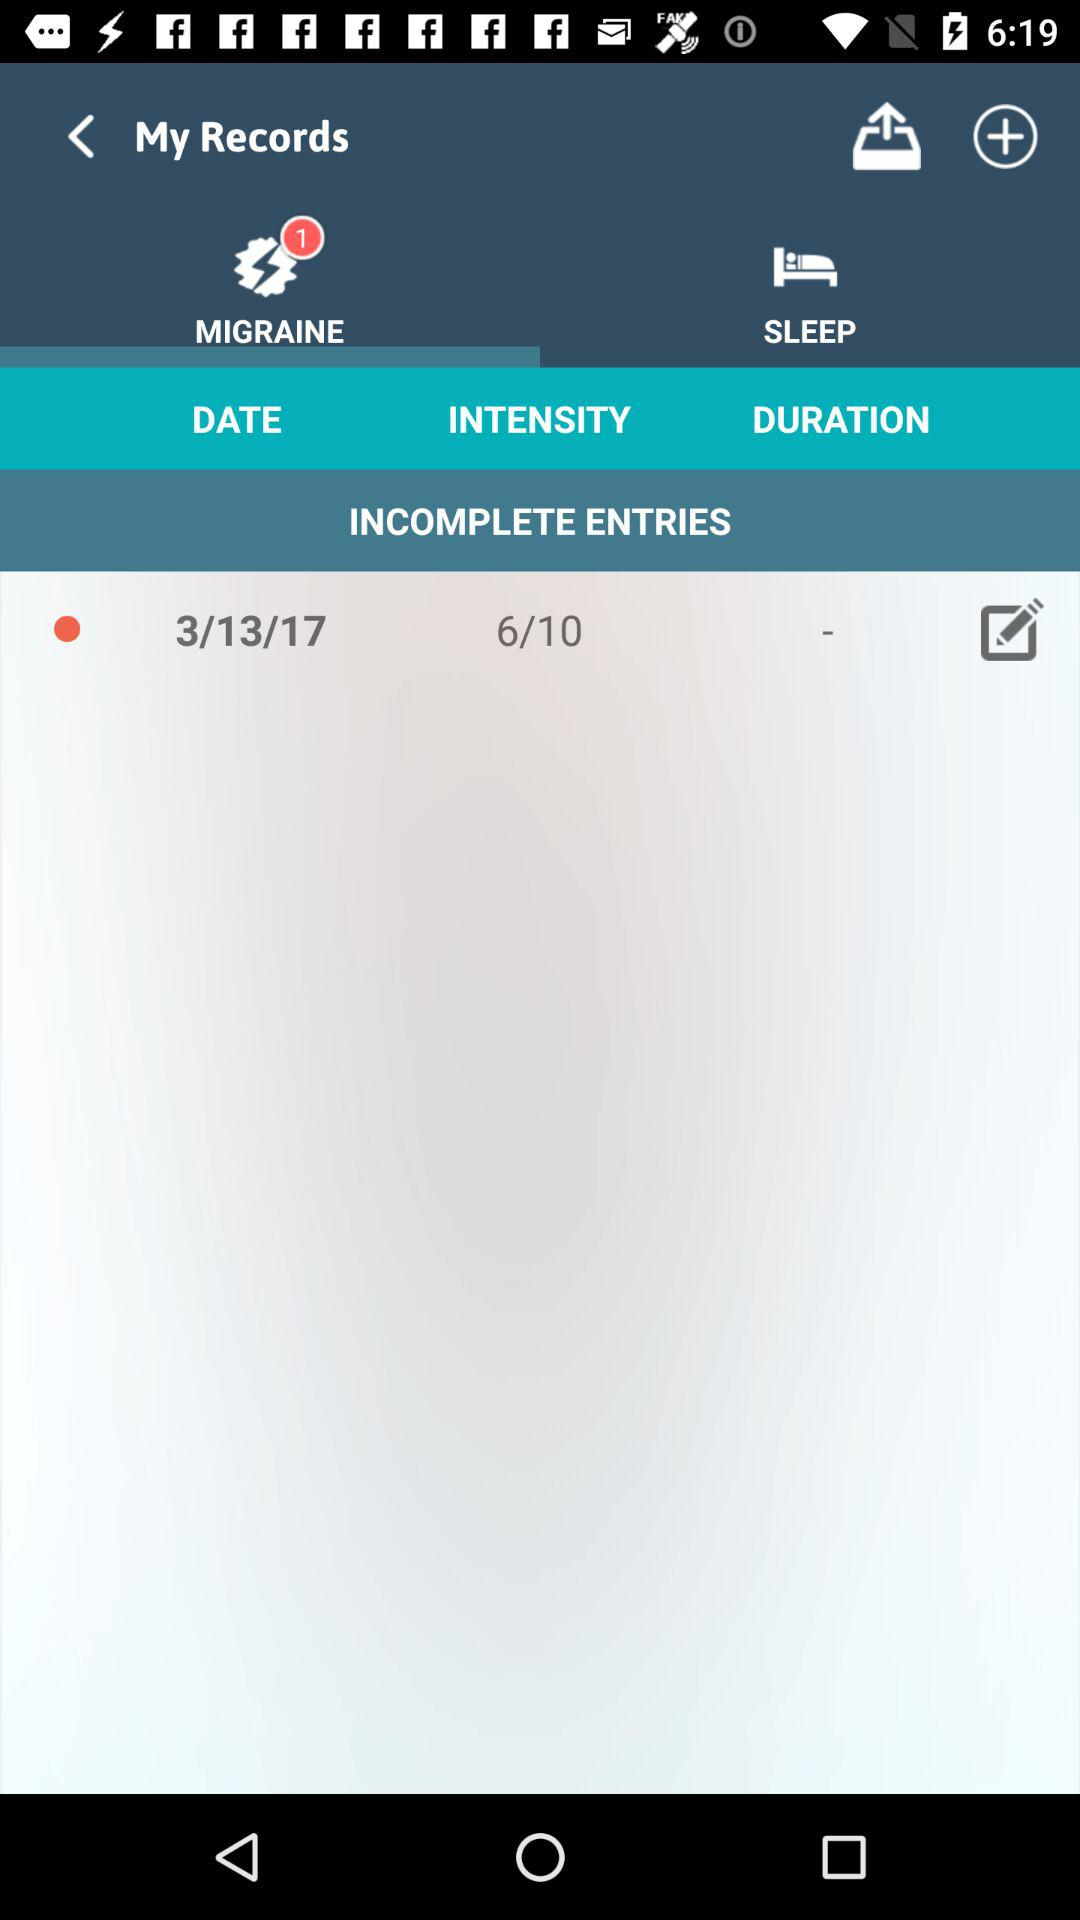How many incomplete entries in total are there? There are 6 incomplete entries in total. 